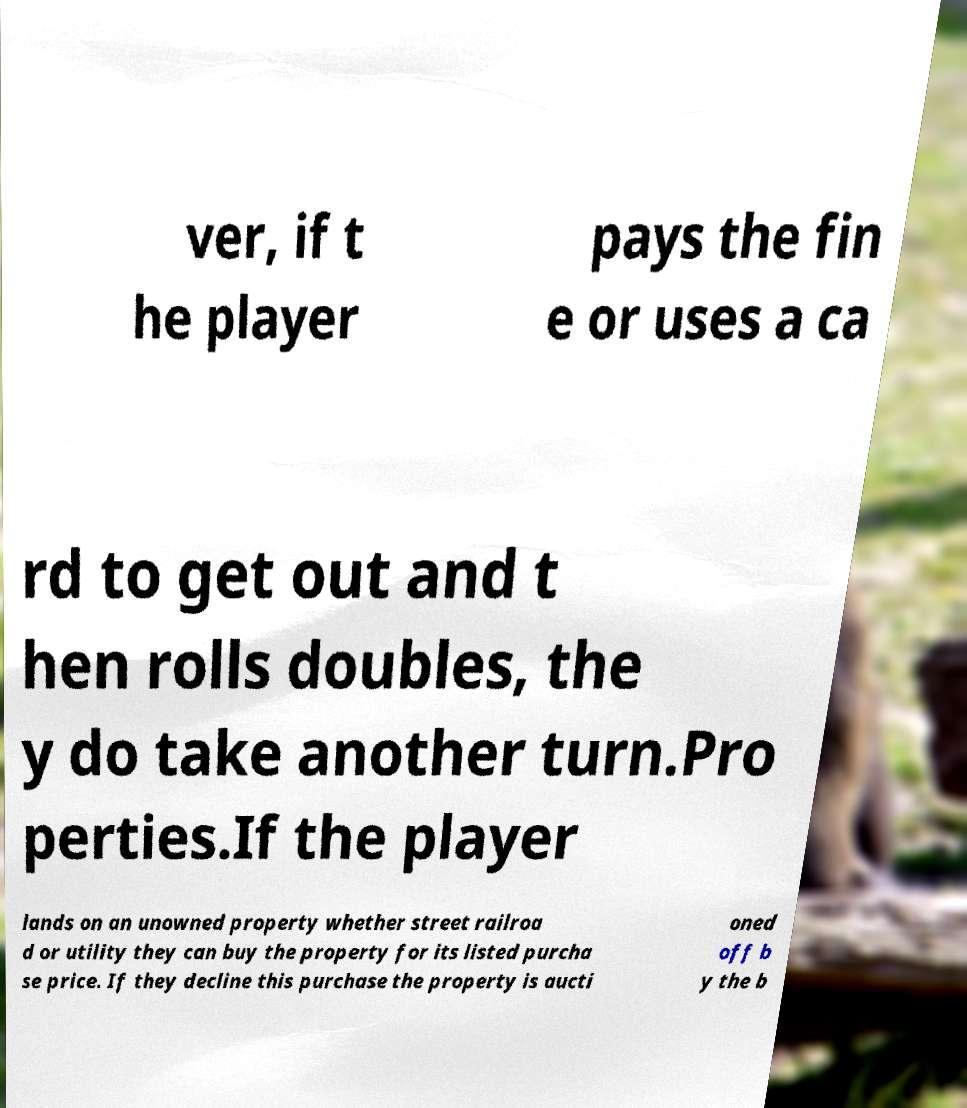Could you extract and type out the text from this image? ver, if t he player pays the fin e or uses a ca rd to get out and t hen rolls doubles, the y do take another turn.Pro perties.If the player lands on an unowned property whether street railroa d or utility they can buy the property for its listed purcha se price. If they decline this purchase the property is aucti oned off b y the b 